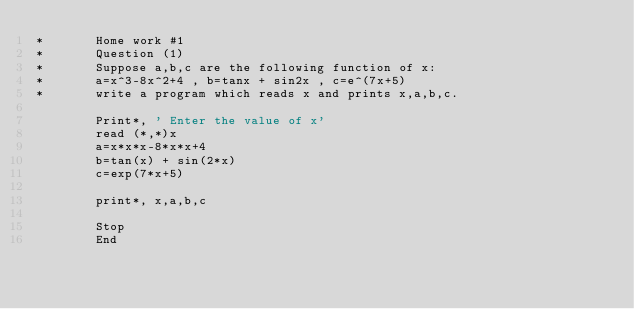Convert code to text. <code><loc_0><loc_0><loc_500><loc_500><_FORTRAN_>*       Home work #1
*       Question (1)
*       Suppose a,b,c are the following function of x:
*       a=x^3-8x^2+4 , b=tanx + sin2x , c=e^(7x+5)
*       write a program which reads x and prints x,a,b,c.

        Print*, ' Enter the value of x'
        read (*,*)x
        a=x*x*x-8*x*x+4
        b=tan(x) + sin(2*x)
        c=exp(7*x+5)
        
        print*, x,a,b,c
        
        Stop
        End
        
</code> 